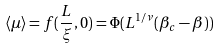Convert formula to latex. <formula><loc_0><loc_0><loc_500><loc_500>\langle \mu \rangle = f ( \frac { L } { \xi } , 0 ) = \Phi ( L ^ { 1 / \nu } ( \beta _ { c } - \beta ) )</formula> 